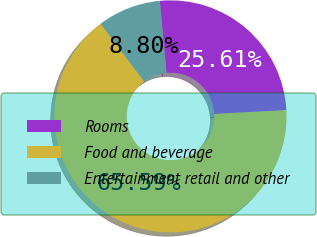Convert chart to OTSL. <chart><loc_0><loc_0><loc_500><loc_500><pie_chart><fcel>Rooms<fcel>Food and beverage<fcel>Entertainment retail and other<nl><fcel>25.61%<fcel>65.59%<fcel>8.8%<nl></chart> 